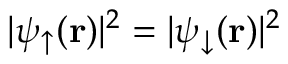<formula> <loc_0><loc_0><loc_500><loc_500>| \psi _ { \uparrow } ( { r } ) | ^ { 2 } = | \psi _ { \downarrow } ( { r } ) | ^ { 2 }</formula> 